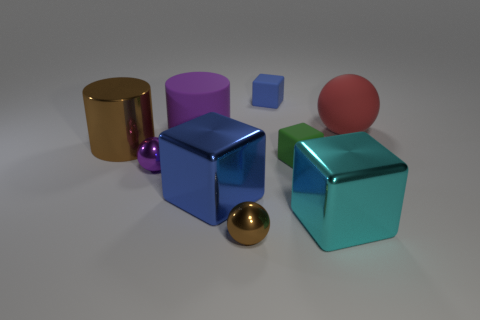Is the size of the matte ball the same as the cyan block?
Keep it short and to the point. Yes. Are there more brown shiny balls in front of the green block than tiny shiny balls?
Keep it short and to the point. No. What is the size of the purple sphere that is the same material as the small brown thing?
Your response must be concise. Small. Are there any tiny green rubber things behind the blue matte cube?
Make the answer very short. No. Do the big blue object and the red matte object have the same shape?
Provide a succinct answer. No. What size is the metal block right of the brown metal thing right of the blue thing in front of the small blue rubber thing?
Give a very brief answer. Large. What material is the purple sphere?
Provide a short and direct response. Metal. What size is the sphere that is the same color as the big metal cylinder?
Your answer should be very brief. Small. There is a large red rubber thing; is it the same shape as the small matte thing that is in front of the metal cylinder?
Your answer should be very brief. No. The block that is to the left of the brown metallic object that is in front of the big metallic object that is behind the small purple metal ball is made of what material?
Keep it short and to the point. Metal. 